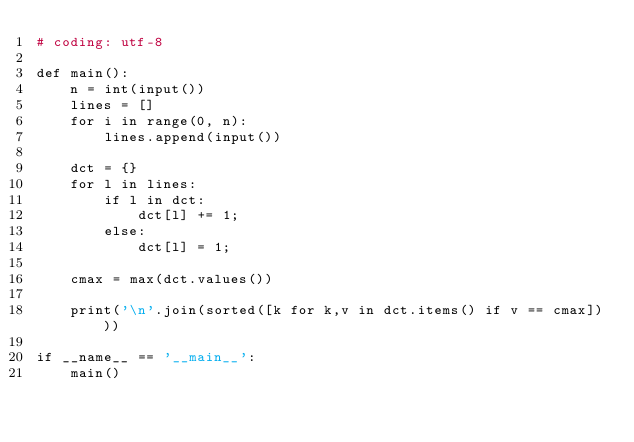<code> <loc_0><loc_0><loc_500><loc_500><_Python_># coding: utf-8

def main():
    n = int(input())
    lines = []
    for i in range(0, n):
        lines.append(input())

    dct = {}
    for l in lines:
        if l in dct:
            dct[l] += 1;
        else:
            dct[l] = 1;

    cmax = max(dct.values())

    print('\n'.join(sorted([k for k,v in dct.items() if v == cmax])))

if __name__ == '__main__':
    main()
</code> 